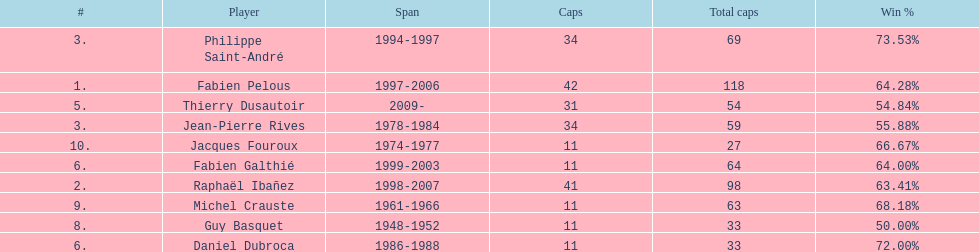Who had the largest win percentage? Philippe Saint-André. 